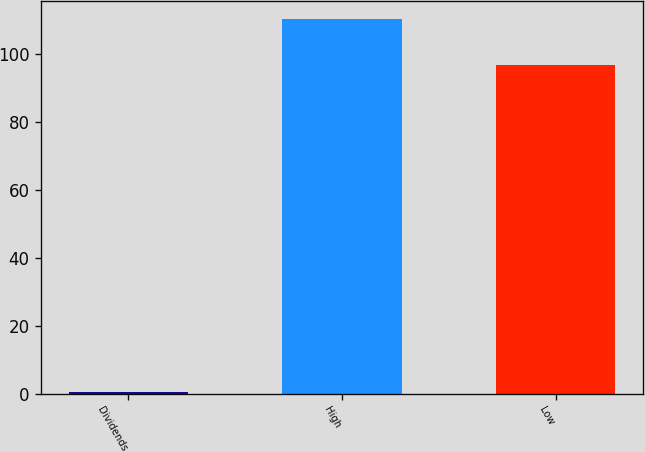<chart> <loc_0><loc_0><loc_500><loc_500><bar_chart><fcel>Dividends<fcel>High<fcel>Low<nl><fcel>0.5<fcel>110.26<fcel>96.76<nl></chart> 